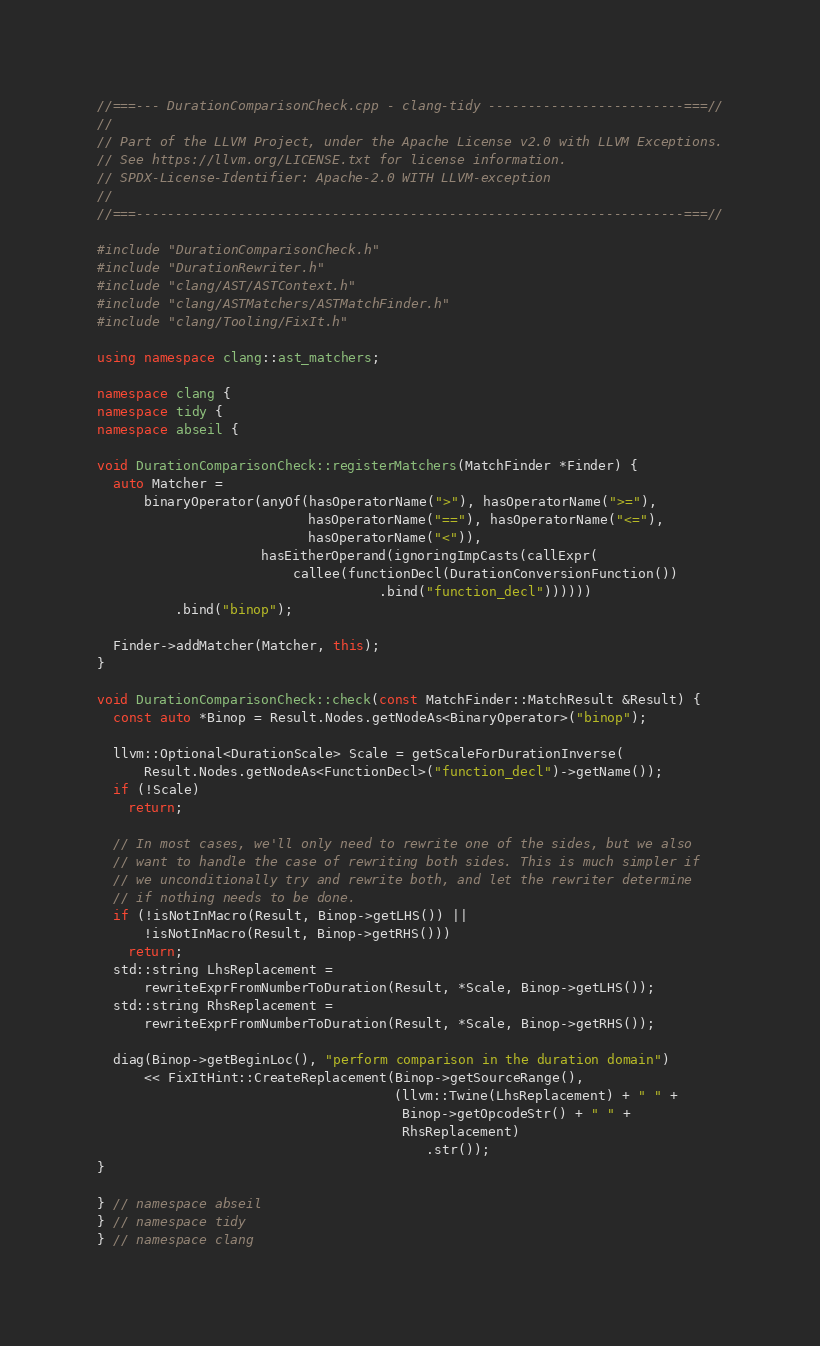Convert code to text. <code><loc_0><loc_0><loc_500><loc_500><_C++_>//===--- DurationComparisonCheck.cpp - clang-tidy -------------------------===//
//
// Part of the LLVM Project, under the Apache License v2.0 with LLVM Exceptions.
// See https://llvm.org/LICENSE.txt for license information.
// SPDX-License-Identifier: Apache-2.0 WITH LLVM-exception
//
//===----------------------------------------------------------------------===//

#include "DurationComparisonCheck.h"
#include "DurationRewriter.h"
#include "clang/AST/ASTContext.h"
#include "clang/ASTMatchers/ASTMatchFinder.h"
#include "clang/Tooling/FixIt.h"

using namespace clang::ast_matchers;

namespace clang {
namespace tidy {
namespace abseil {

void DurationComparisonCheck::registerMatchers(MatchFinder *Finder) {
  auto Matcher =
      binaryOperator(anyOf(hasOperatorName(">"), hasOperatorName(">="),
                           hasOperatorName("=="), hasOperatorName("<="),
                           hasOperatorName("<")),
                     hasEitherOperand(ignoringImpCasts(callExpr(
                         callee(functionDecl(DurationConversionFunction())
                                    .bind("function_decl"))))))
          .bind("binop");

  Finder->addMatcher(Matcher, this);
}

void DurationComparisonCheck::check(const MatchFinder::MatchResult &Result) {
  const auto *Binop = Result.Nodes.getNodeAs<BinaryOperator>("binop");

  llvm::Optional<DurationScale> Scale = getScaleForDurationInverse(
      Result.Nodes.getNodeAs<FunctionDecl>("function_decl")->getName());
  if (!Scale)
    return;

  // In most cases, we'll only need to rewrite one of the sides, but we also
  // want to handle the case of rewriting both sides. This is much simpler if
  // we unconditionally try and rewrite both, and let the rewriter determine
  // if nothing needs to be done.
  if (!isNotInMacro(Result, Binop->getLHS()) ||
      !isNotInMacro(Result, Binop->getRHS()))
    return;
  std::string LhsReplacement =
      rewriteExprFromNumberToDuration(Result, *Scale, Binop->getLHS());
  std::string RhsReplacement =
      rewriteExprFromNumberToDuration(Result, *Scale, Binop->getRHS());

  diag(Binop->getBeginLoc(), "perform comparison in the duration domain")
      << FixItHint::CreateReplacement(Binop->getSourceRange(),
                                      (llvm::Twine(LhsReplacement) + " " +
                                       Binop->getOpcodeStr() + " " +
                                       RhsReplacement)
                                          .str());
}

} // namespace abseil
} // namespace tidy
} // namespace clang
</code> 